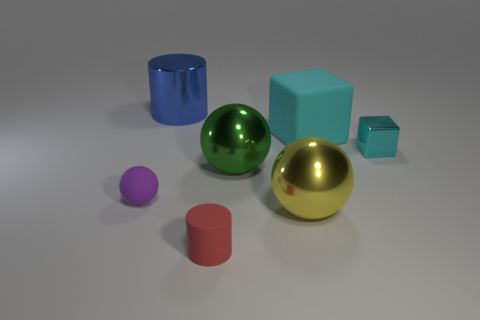There is a metal object that is right of the sphere that is to the right of the metallic sphere behind the purple matte object; what color is it?
Offer a very short reply. Cyan. The tiny cylinder is what color?
Provide a short and direct response. Red. Are there more small objects in front of the tiny sphere than small purple things that are right of the small metallic block?
Give a very brief answer. Yes. Does the red rubber object have the same shape as the small matte thing that is on the left side of the large blue shiny object?
Your response must be concise. No. There is a shiny object left of the green ball; does it have the same size as the metallic object that is on the right side of the yellow metallic thing?
Your response must be concise. No. Is there a large yellow metal thing that is to the left of the object behind the block to the left of the small block?
Provide a succinct answer. No. Are there fewer large blue cylinders in front of the big cyan cube than yellow metal balls to the left of the cyan metallic block?
Offer a terse response. Yes. The yellow object that is the same material as the large cylinder is what shape?
Offer a very short reply. Sphere. What size is the cylinder that is in front of the rubber object on the left side of the big metallic thing left of the small cylinder?
Make the answer very short. Small. Are there more large yellow balls than cylinders?
Offer a very short reply. No. 